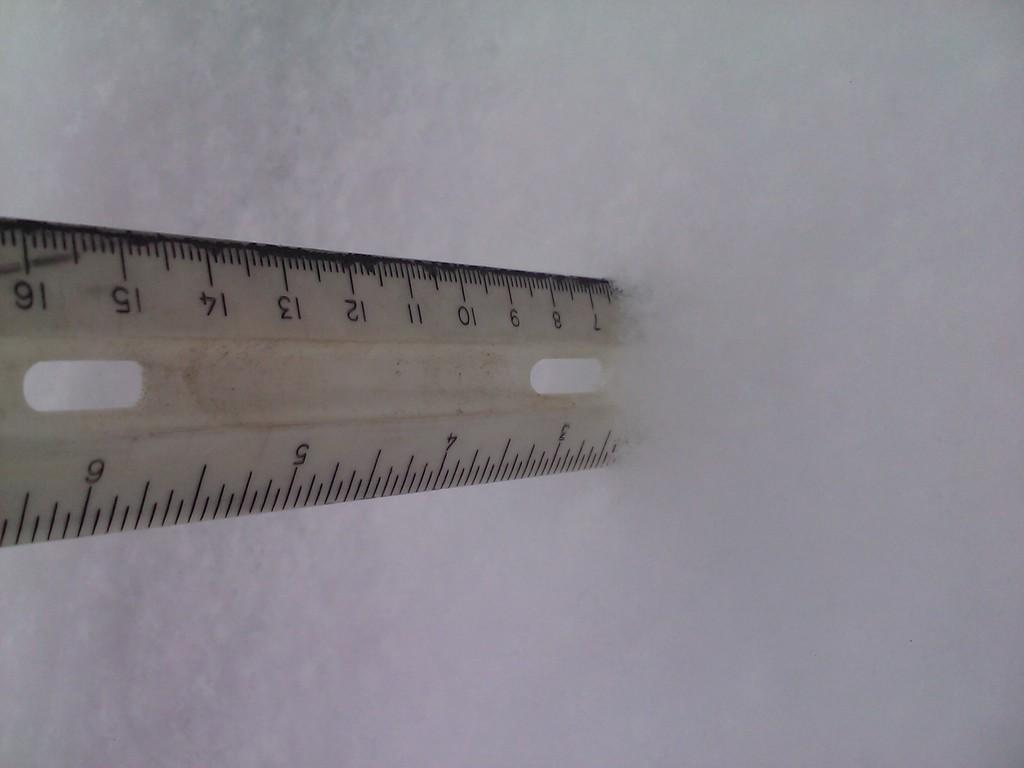<image>
Summarize the visual content of the image. A ruler shows that the snow is almost 7 cm deep. 